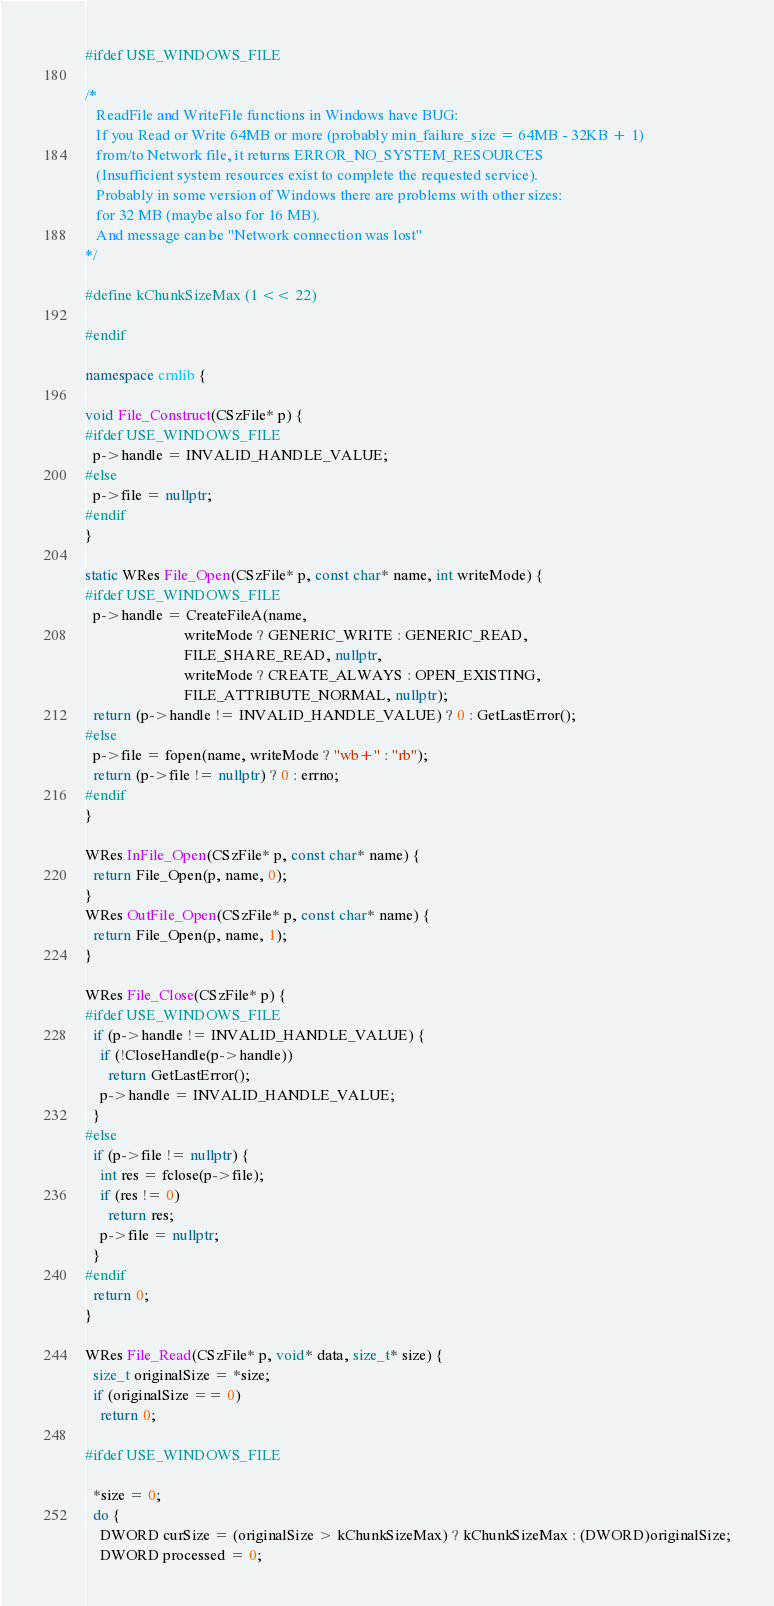Convert code to text. <code><loc_0><loc_0><loc_500><loc_500><_C++_>#ifdef USE_WINDOWS_FILE

/*
   ReadFile and WriteFile functions in Windows have BUG:
   If you Read or Write 64MB or more (probably min_failure_size = 64MB - 32KB + 1)
   from/to Network file, it returns ERROR_NO_SYSTEM_RESOURCES
   (Insufficient system resources exist to complete the requested service).
   Probably in some version of Windows there are problems with other sizes:
   for 32 MB (maybe also for 16 MB).
   And message can be "Network connection was lost"
*/

#define kChunkSizeMax (1 << 22)

#endif

namespace crnlib {

void File_Construct(CSzFile* p) {
#ifdef USE_WINDOWS_FILE
  p->handle = INVALID_HANDLE_VALUE;
#else
  p->file = nullptr;
#endif
}

static WRes File_Open(CSzFile* p, const char* name, int writeMode) {
#ifdef USE_WINDOWS_FILE
  p->handle = CreateFileA(name,
                          writeMode ? GENERIC_WRITE : GENERIC_READ,
                          FILE_SHARE_READ, nullptr,
                          writeMode ? CREATE_ALWAYS : OPEN_EXISTING,
                          FILE_ATTRIBUTE_NORMAL, nullptr);
  return (p->handle != INVALID_HANDLE_VALUE) ? 0 : GetLastError();
#else
  p->file = fopen(name, writeMode ? "wb+" : "rb");
  return (p->file != nullptr) ? 0 : errno;
#endif
}

WRes InFile_Open(CSzFile* p, const char* name) {
  return File_Open(p, name, 0);
}
WRes OutFile_Open(CSzFile* p, const char* name) {
  return File_Open(p, name, 1);
}

WRes File_Close(CSzFile* p) {
#ifdef USE_WINDOWS_FILE
  if (p->handle != INVALID_HANDLE_VALUE) {
    if (!CloseHandle(p->handle))
      return GetLastError();
    p->handle = INVALID_HANDLE_VALUE;
  }
#else
  if (p->file != nullptr) {
    int res = fclose(p->file);
    if (res != 0)
      return res;
    p->file = nullptr;
  }
#endif
  return 0;
}

WRes File_Read(CSzFile* p, void* data, size_t* size) {
  size_t originalSize = *size;
  if (originalSize == 0)
    return 0;

#ifdef USE_WINDOWS_FILE

  *size = 0;
  do {
    DWORD curSize = (originalSize > kChunkSizeMax) ? kChunkSizeMax : (DWORD)originalSize;
    DWORD processed = 0;</code> 